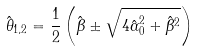<formula> <loc_0><loc_0><loc_500><loc_500>\hat { \theta } _ { 1 , 2 } = \frac { 1 } { 2 } \left ( \hat { \beta } \pm \sqrt { 4 \hat { \alpha } _ { 0 } ^ { 2 } + \hat { \beta } ^ { 2 } } \right )</formula> 